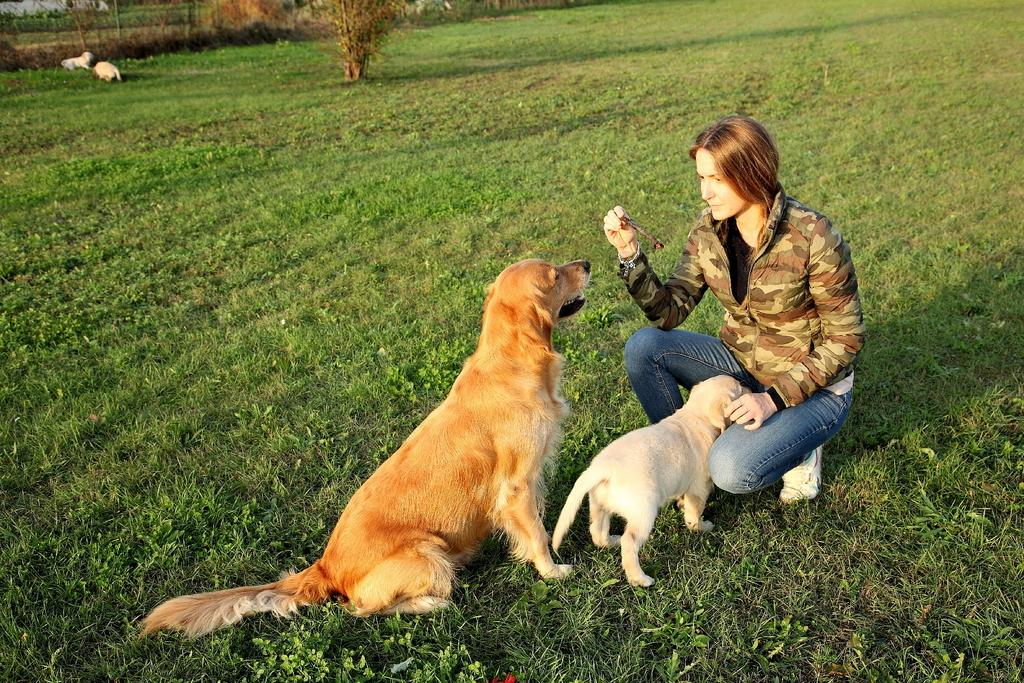What is the lady doing in the image? There is a lady sitting in the image. Are there any animals present in the image? Yes, there are two dogs in front of the lady. What type of elbow treatment is the lady receiving in the image? There is no mention of an elbow or any treatment in the image; it simply shows a lady sitting with two dogs in front of her. --- Facts: 1. There is a car in the image. 2. The car is parked on the street. 3. There are trees on both sides of the street. 4. The sky is visible in the image. Absurd Topics: fish, dance, mountain Conversation: What is the main subject of the image? The main subject of the image is a car. Where is the car located in the image? The car is parked on the street. What can be seen on both sides of the street in the image? There are trees on both sides of the street. What is visible in the background of the image? The sky is visible in the image. Reasoning: Let's think step by step in order to produce the conversation. We start by identifying the main subject in the image, which is the car. Then, we expand the conversation to include the location of the car, the trees on both sides of the street, and the visible sky in the background. Each question is designed to elicit a specific detail about the image that is known from the provided facts. Absurd Question/Answer: Can you see any fish swimming in the image? No, there are no fish present in the image; it features a car parked on the street with trees on both sides and a visible sky. 